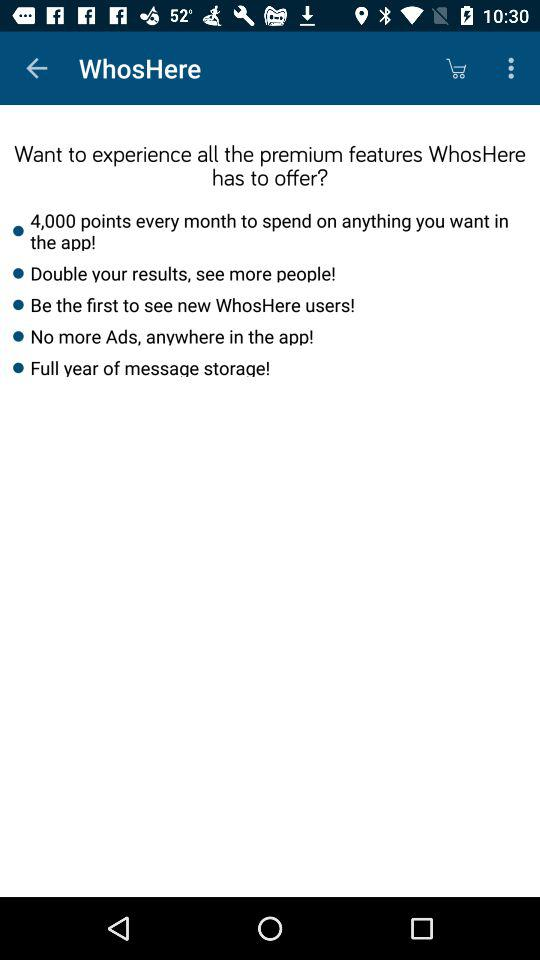How many points are offered per month? 4,000 